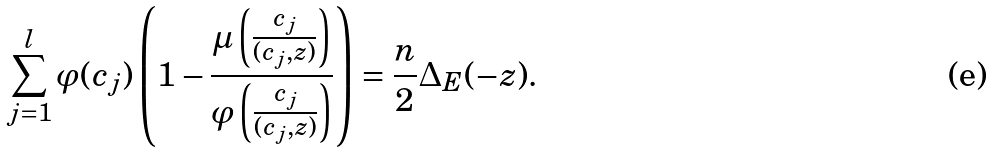<formula> <loc_0><loc_0><loc_500><loc_500>\sum _ { j = 1 } ^ { l } \varphi ( c _ { j } ) \left ( 1 - \frac { \mu \left ( \frac { c _ { j } } { ( c _ { j } , z ) } \right ) } { \varphi \left ( \frac { c _ { j } } { ( c _ { j } , z ) } \right ) } \right ) = \frac { n } { 2 } \Delta _ { E } ( - z ) .</formula> 